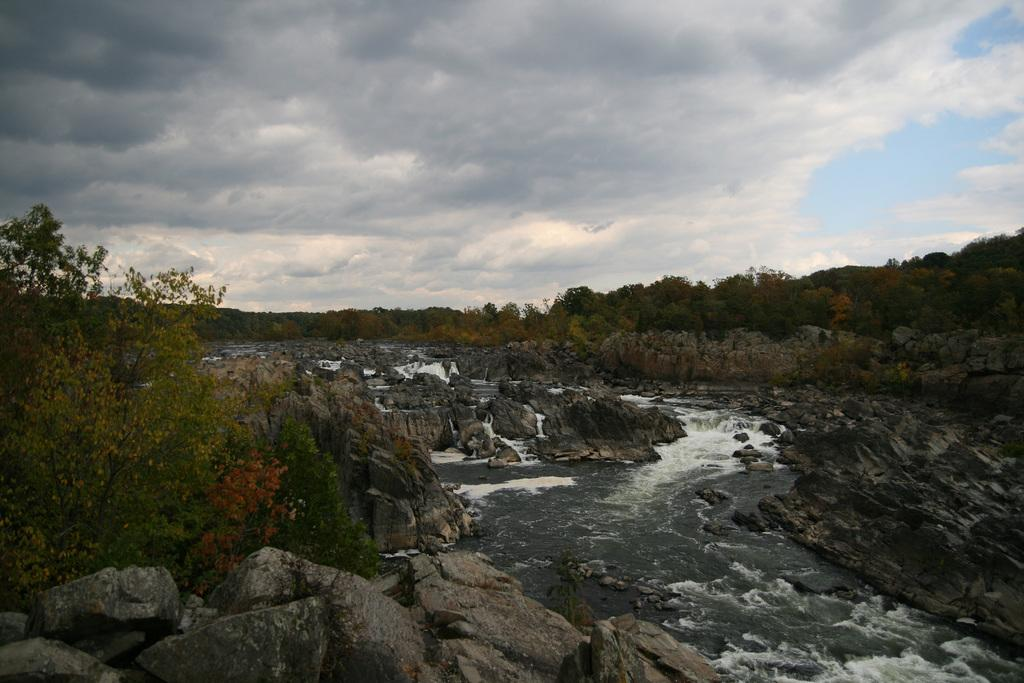What is the primary element visible in the image? There is water in the image. What else can be seen in the image besides water? There is a group of stones and trees in the image. How would you describe the sky in the image? The sky is visible in the background of the image, and it appears to be cloudy. What type of scarf is being used to solve the riddle in the image? There is no scarf or riddle present in the image. 